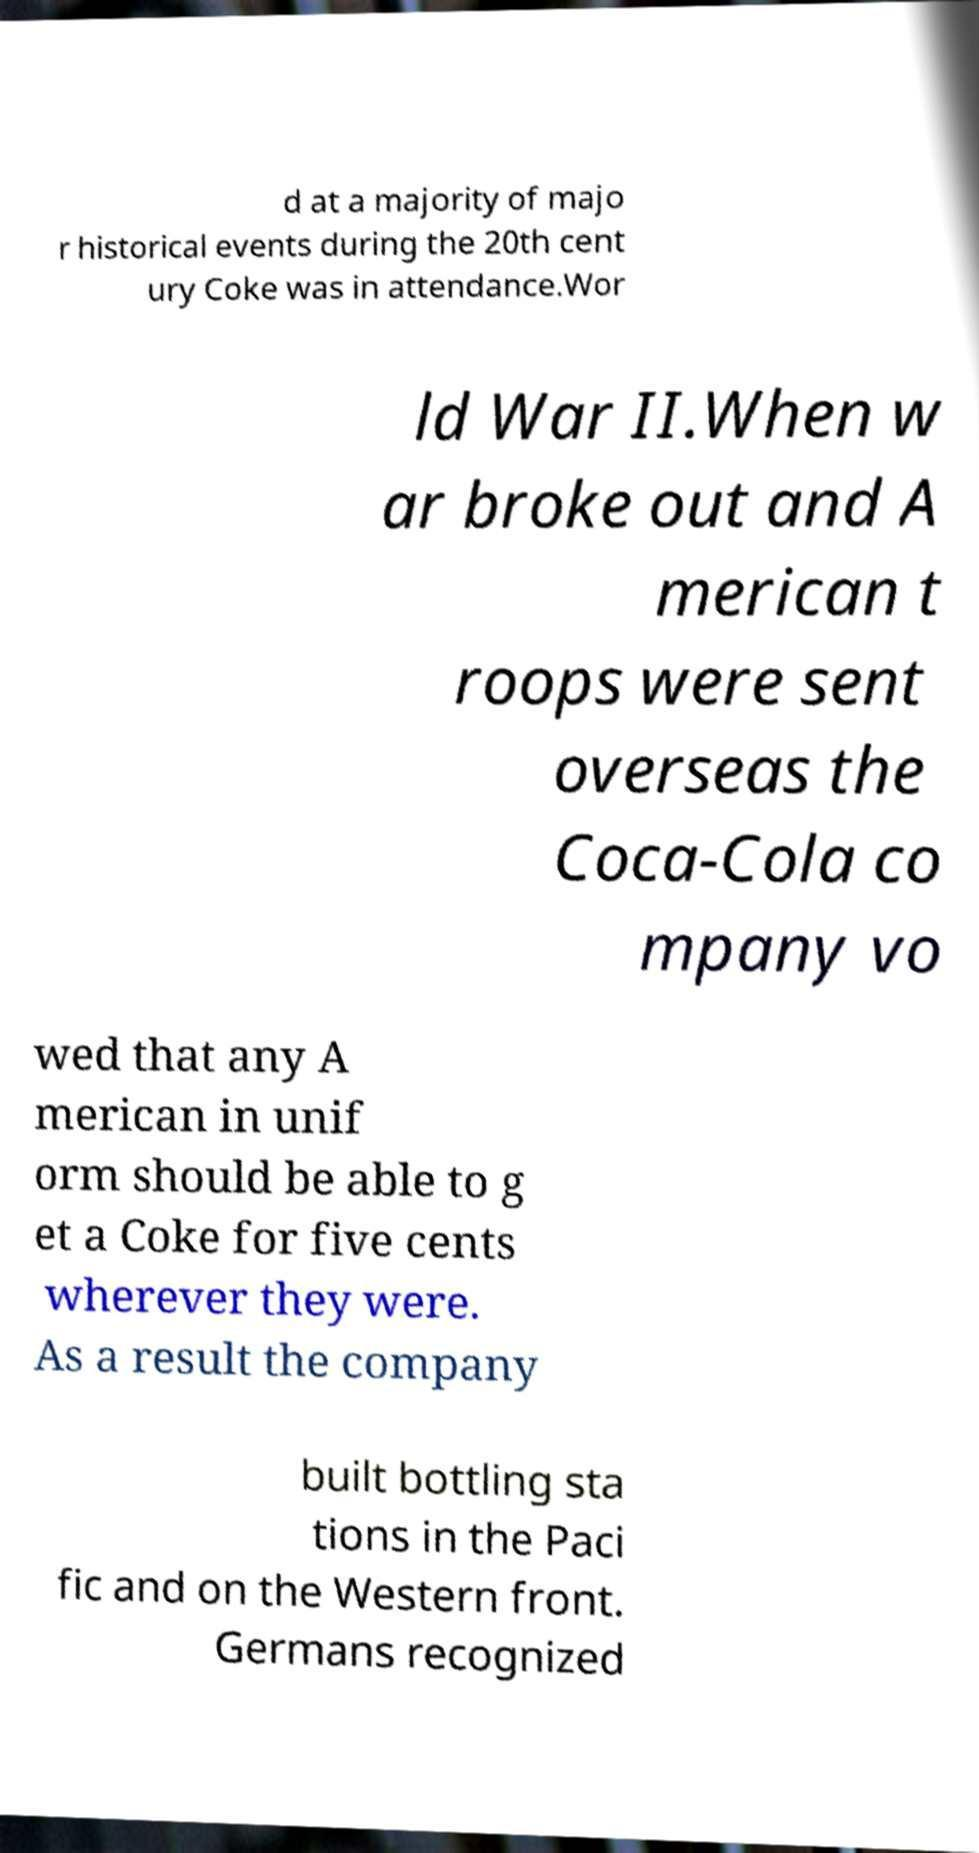Could you extract and type out the text from this image? d at a majority of majo r historical events during the 20th cent ury Coke was in attendance.Wor ld War II.When w ar broke out and A merican t roops were sent overseas the Coca-Cola co mpany vo wed that any A merican in unif orm should be able to g et a Coke for five cents wherever they were. As a result the company built bottling sta tions in the Paci fic and on the Western front. Germans recognized 